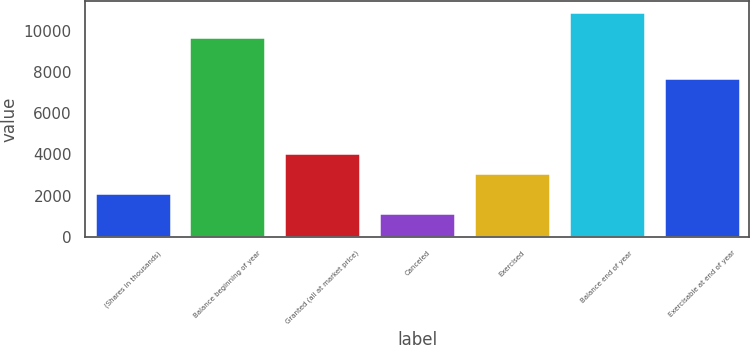<chart> <loc_0><loc_0><loc_500><loc_500><bar_chart><fcel>(Shares in thousands)<fcel>Balance beginning of year<fcel>Granted (all at market price)<fcel>Canceled<fcel>Exercised<fcel>Balance end of year<fcel>Exercisable at end of year<nl><fcel>2144.8<fcel>9698<fcel>4092.4<fcel>1171<fcel>3118.6<fcel>10909<fcel>7743<nl></chart> 